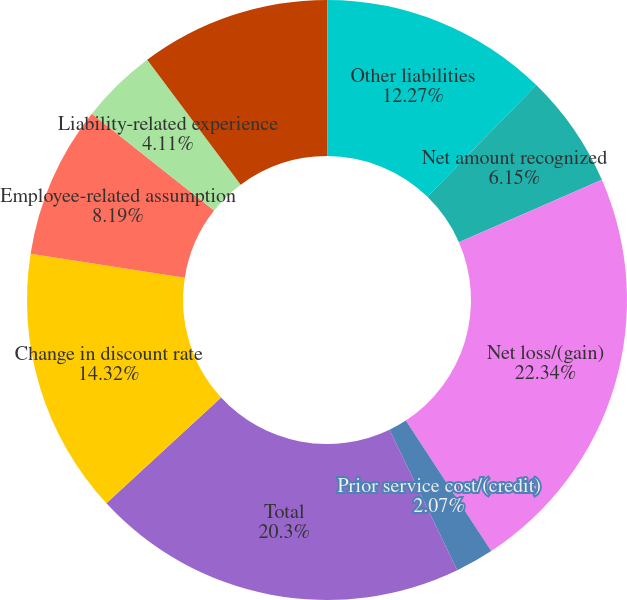Convert chart. <chart><loc_0><loc_0><loc_500><loc_500><pie_chart><fcel>Other current liabilities<fcel>Other liabilities<fcel>Net amount recognized<fcel>Net loss/(gain)<fcel>Prior service cost/(credit)<fcel>Total<fcel>Change in discount rate<fcel>Employee-related assumption<fcel>Liability-related experience<fcel>Actual asset return different<nl><fcel>0.02%<fcel>12.27%<fcel>6.15%<fcel>22.34%<fcel>2.07%<fcel>20.3%<fcel>14.32%<fcel>8.19%<fcel>4.11%<fcel>10.23%<nl></chart> 